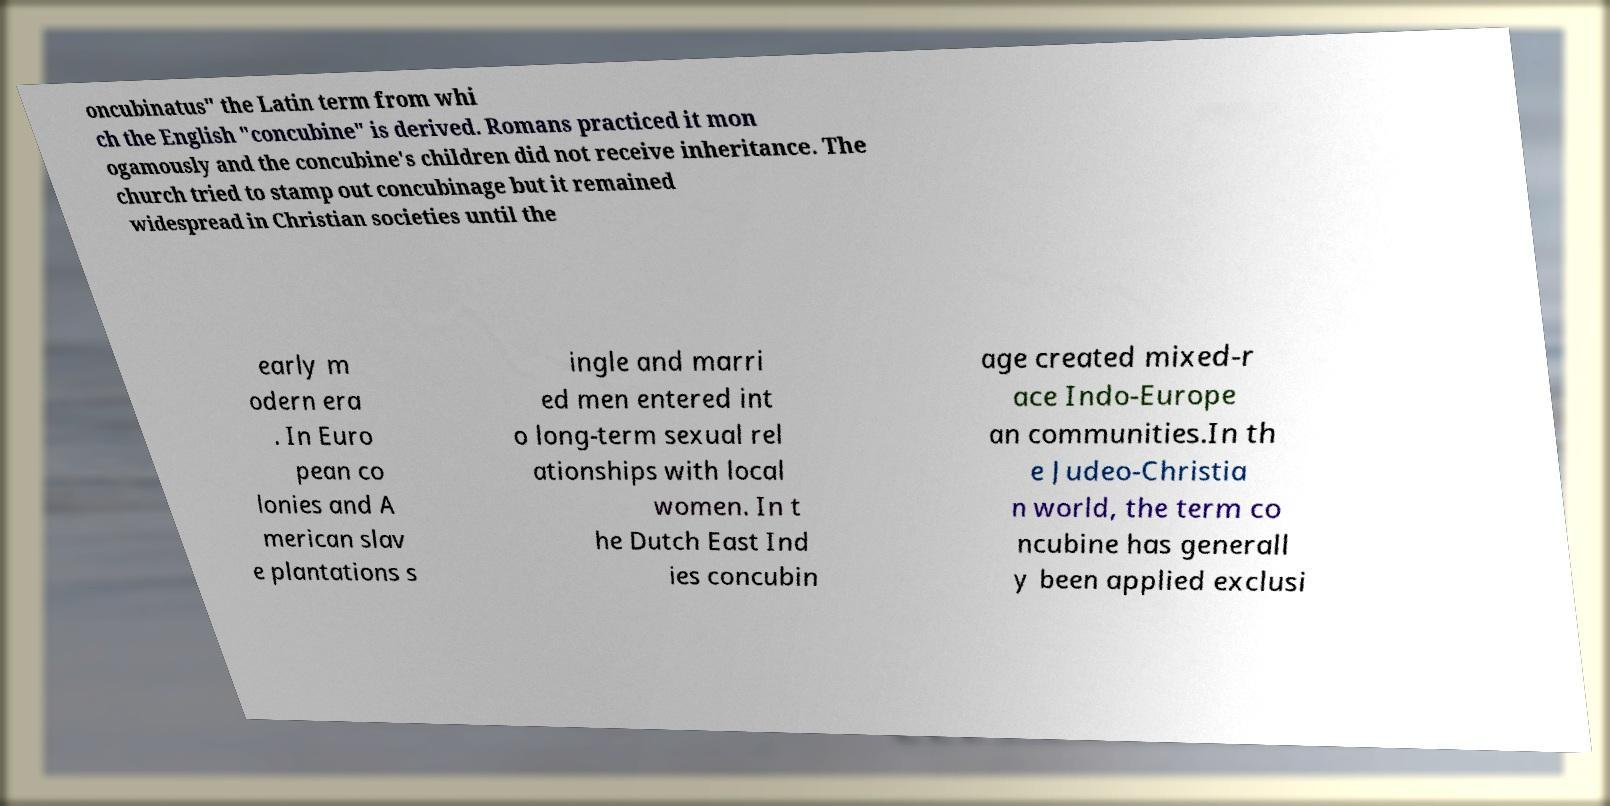For documentation purposes, I need the text within this image transcribed. Could you provide that? oncubinatus" the Latin term from whi ch the English "concubine" is derived. Romans practiced it mon ogamously and the concubine's children did not receive inheritance. The church tried to stamp out concubinage but it remained widespread in Christian societies until the early m odern era . In Euro pean co lonies and A merican slav e plantations s ingle and marri ed men entered int o long-term sexual rel ationships with local women. In t he Dutch East Ind ies concubin age created mixed-r ace Indo-Europe an communities.In th e Judeo-Christia n world, the term co ncubine has generall y been applied exclusi 